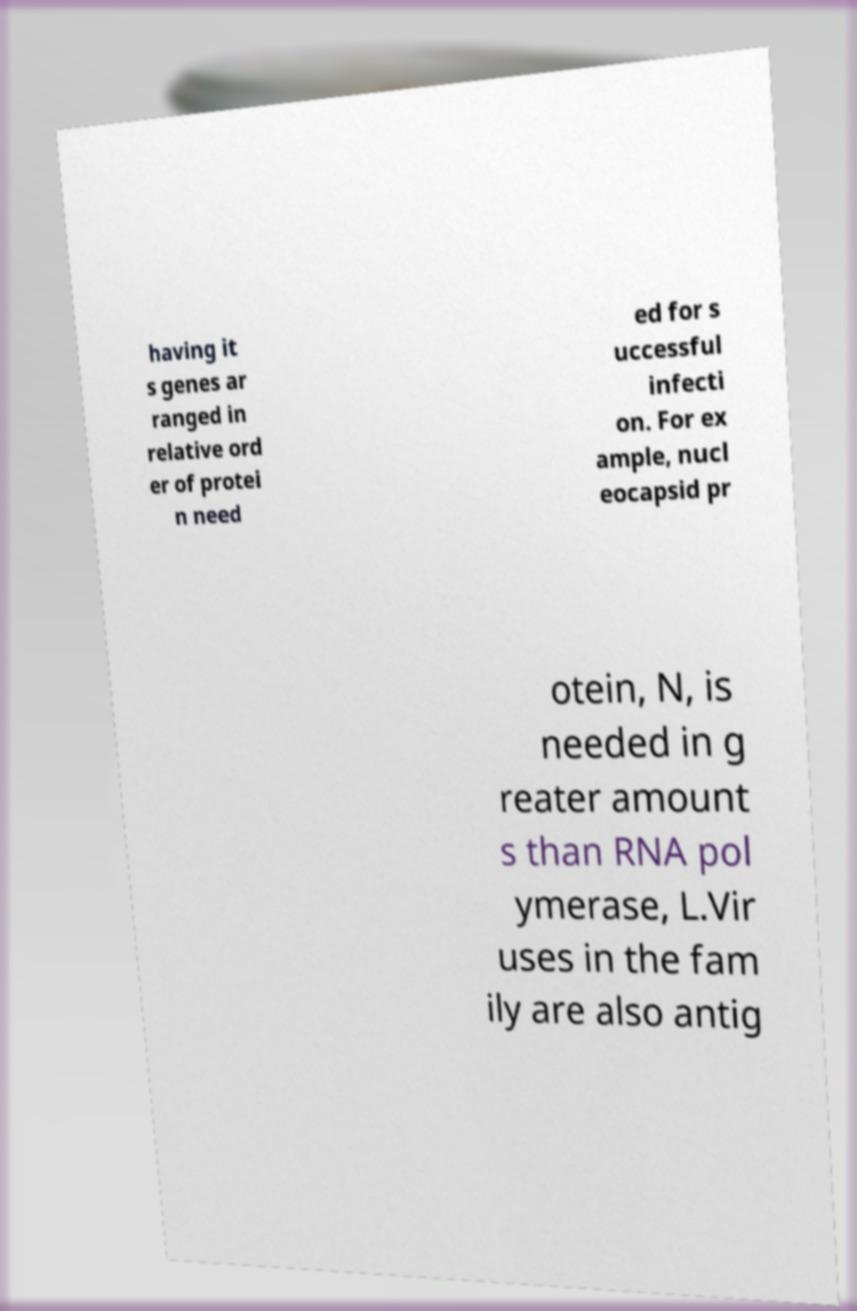What messages or text are displayed in this image? I need them in a readable, typed format. having it s genes ar ranged in relative ord er of protei n need ed for s uccessful infecti on. For ex ample, nucl eocapsid pr otein, N, is needed in g reater amount s than RNA pol ymerase, L.Vir uses in the fam ily are also antig 